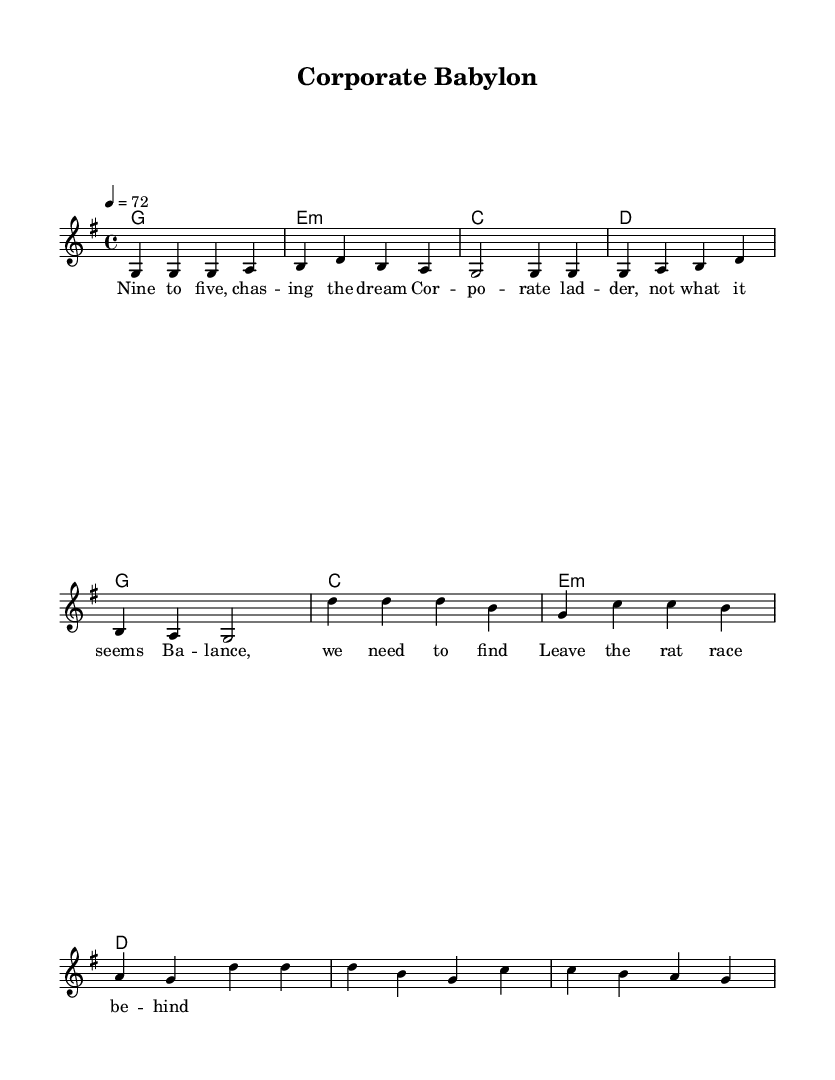What is the key signature of this music? The key signature is G major, which has one sharp (F#). This information can typically be found at the beginning of the staff in the key signature section.
Answer: G major What is the time signature of this music? The time signature is 4/4, which indicates four beats per measure, and can be found at the beginning of the score, just after the key signature.
Answer: 4/4 What is the tempo marking of this piece? The tempo is marked as 4 = 72, meaning that the quarter note gets 72 beats per minute. This marking is usually located at the beginning of the score, under the time signature.
Answer: 72 How many bars are there in the verse section? The verse section consists of 4 bars, which can be counted by looking at the measure lines in the music. Each group of notes separated by vertical lines indicates one bar.
Answer: 4 What is the overall feel or theme represented by the lyrics? The theme of the lyrics focuses on work-life balance and the need to escape from stress, illustrated by phrases like "chasing the dream" and "leave the rat race behind." Such themes are common in reggae music, emphasizing relaxation and relief from stress.
Answer: Work-life balance What are the main chords used in the harmony? The main chords used throughout the piece are G, E minor, C, and D. These chords can be identified by the symbols placed above the staff indicating chord changes.
Answer: G, E minor, C, D What is the primary mood conveyed by the chorus? The primary mood conveyed in the chorus is one of seeking balance and tranquility, as expressed in the lyrics about needing to find balance and leaving behind the rat race, typical in reggae music which often promotes peace and relaxation.
Answer: Tranquility 